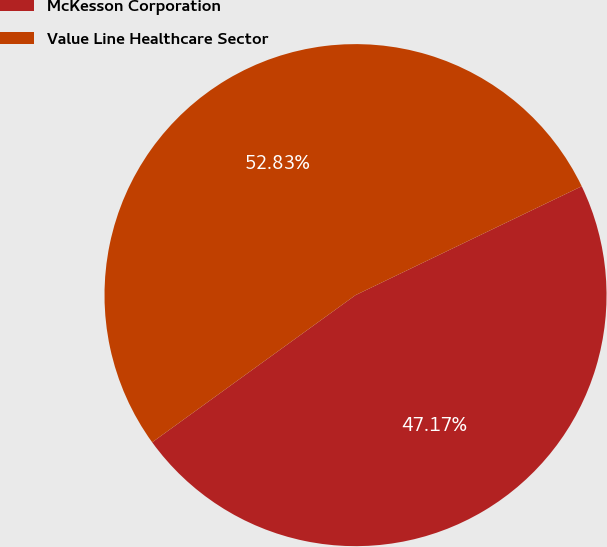<chart> <loc_0><loc_0><loc_500><loc_500><pie_chart><fcel>McKesson Corporation<fcel>Value Line Healthcare Sector<nl><fcel>47.17%<fcel>52.83%<nl></chart> 